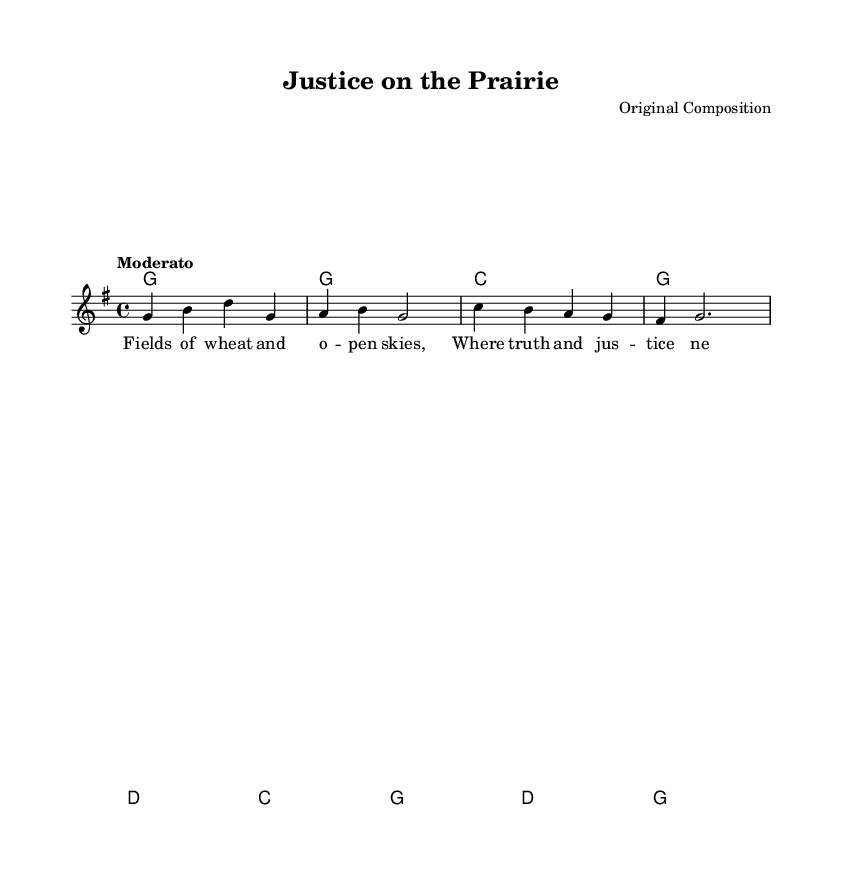What is the key signature of this music? The key signature indicated in the global section shows one sharp, which corresponds to the key of G major.
Answer: G major What is the time signature of this music? The time signature, found at the beginning, is indicated as 4/4. This means there are four beats in each measure.
Answer: 4/4 What is the tempo marking for this piece? The tempo marking is given as "Moderato", which suggests a moderate pace of the music.
Answer: Moderato What is the first lyric line of the song? The first lyric line is found in the verse one section, reading "Fields of wheat and o -- pen skies."
Answer: Fields of wheat and o -- pen skies How many measures are in the first verse? The first verse contains four measures, as indicated by the line breaks in the melody notation.
Answer: 4 What is the harmonic progression for the first four measures? The chords for the first four measures follow a pattern of G, G, C, and G respectively, based on the chord notation provided.
Answer: G, G, C, G What is the structure of the song regarding melody and harmony? The song structure involves a single voice carrying the melody and a separate chord progression providing the harmonies, typical in country music for supporting the narrative.
Answer: Melody and harmonies 